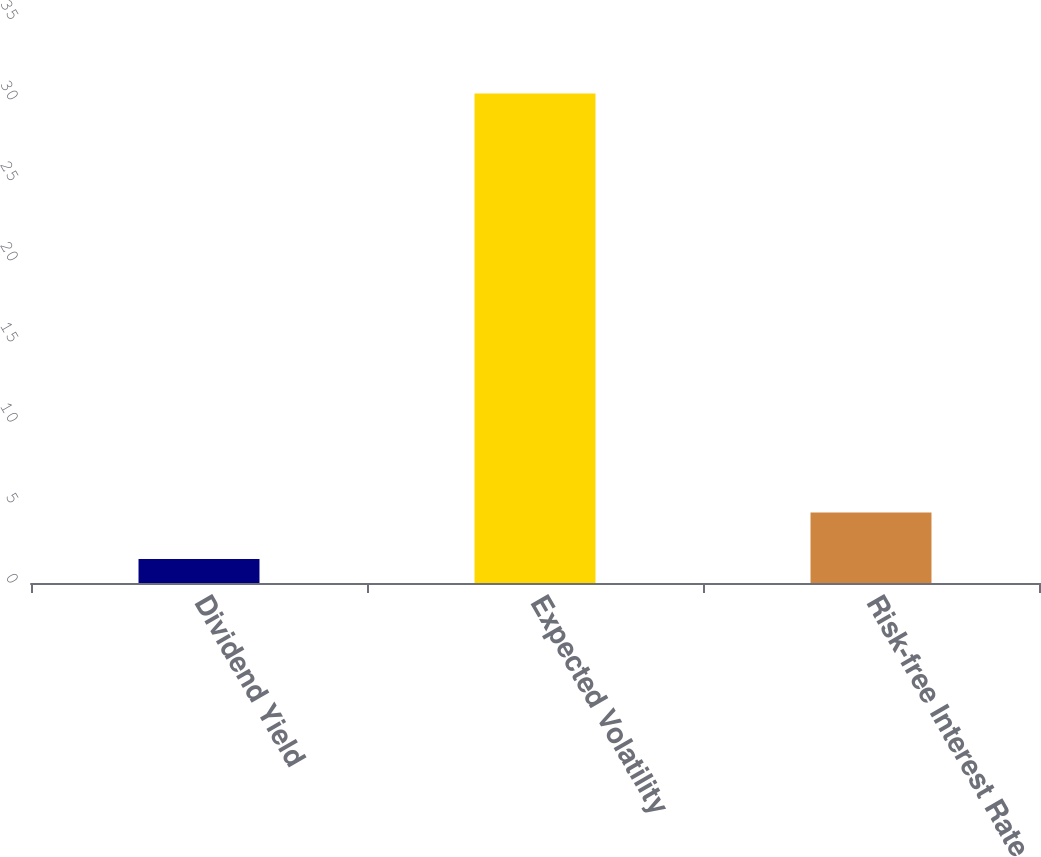<chart> <loc_0><loc_0><loc_500><loc_500><bar_chart><fcel>Dividend Yield<fcel>Expected Volatility<fcel>Risk-free Interest Rate<nl><fcel>1.49<fcel>30.38<fcel>4.38<nl></chart> 